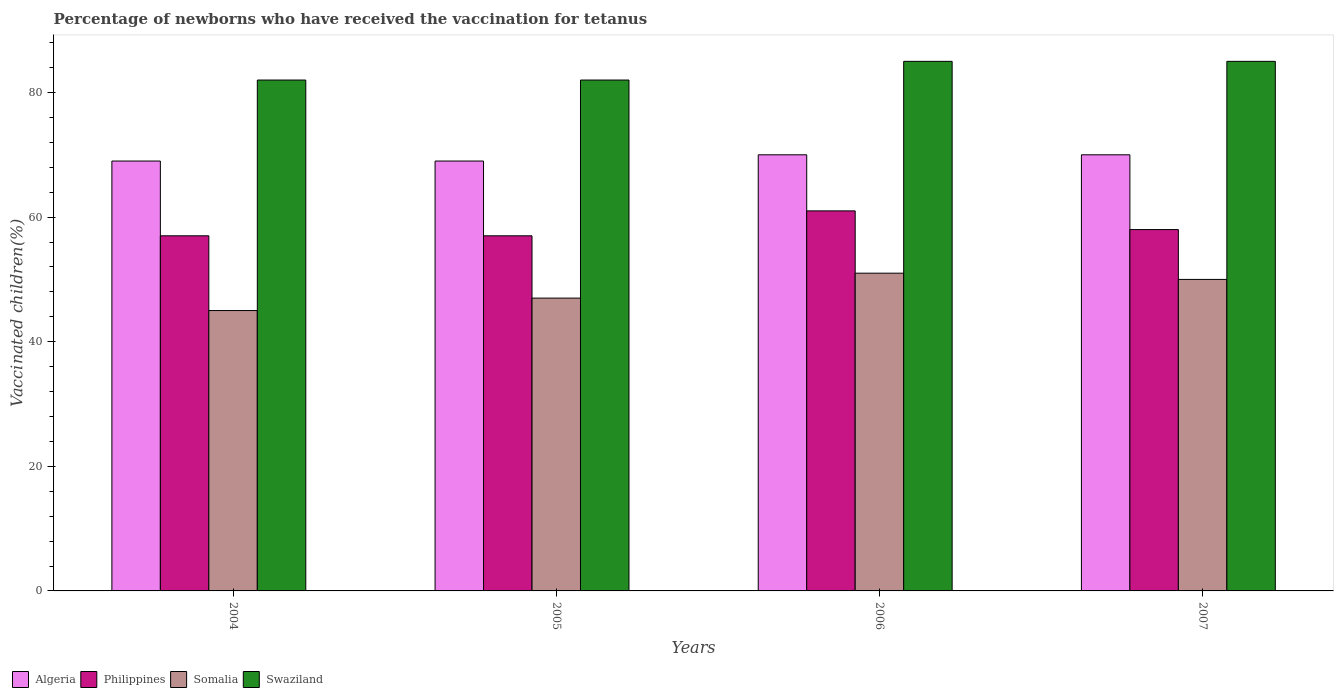In how many cases, is the number of bars for a given year not equal to the number of legend labels?
Your answer should be compact. 0. What is the percentage of vaccinated children in Philippines in 2006?
Keep it short and to the point. 61. Across all years, what is the minimum percentage of vaccinated children in Algeria?
Make the answer very short. 69. In which year was the percentage of vaccinated children in Philippines minimum?
Make the answer very short. 2004. What is the total percentage of vaccinated children in Swaziland in the graph?
Offer a very short reply. 334. What is the difference between the percentage of vaccinated children in Swaziland in 2005 and that in 2006?
Keep it short and to the point. -3. What is the difference between the percentage of vaccinated children in Somalia in 2007 and the percentage of vaccinated children in Swaziland in 2006?
Provide a succinct answer. -35. What is the average percentage of vaccinated children in Swaziland per year?
Offer a very short reply. 83.5. In the year 2005, what is the difference between the percentage of vaccinated children in Philippines and percentage of vaccinated children in Swaziland?
Provide a succinct answer. -25. In how many years, is the percentage of vaccinated children in Somalia greater than 8 %?
Provide a succinct answer. 4. What is the ratio of the percentage of vaccinated children in Philippines in 2004 to that in 2006?
Your response must be concise. 0.93. What is the difference between the highest and the second highest percentage of vaccinated children in Algeria?
Ensure brevity in your answer.  0. In how many years, is the percentage of vaccinated children in Somalia greater than the average percentage of vaccinated children in Somalia taken over all years?
Provide a succinct answer. 2. What does the 3rd bar from the left in 2005 represents?
Offer a terse response. Somalia. What does the 1st bar from the right in 2006 represents?
Keep it short and to the point. Swaziland. How many bars are there?
Ensure brevity in your answer.  16. Are the values on the major ticks of Y-axis written in scientific E-notation?
Your answer should be compact. No. What is the title of the graph?
Your response must be concise. Percentage of newborns who have received the vaccination for tetanus. What is the label or title of the Y-axis?
Provide a succinct answer. Vaccinated children(%). What is the Vaccinated children(%) of Algeria in 2004?
Give a very brief answer. 69. What is the Vaccinated children(%) of Swaziland in 2004?
Offer a very short reply. 82. What is the Vaccinated children(%) of Algeria in 2005?
Offer a terse response. 69. What is the Vaccinated children(%) in Philippines in 2005?
Your answer should be very brief. 57. What is the Vaccinated children(%) in Philippines in 2006?
Your response must be concise. 61. What is the Vaccinated children(%) in Swaziland in 2006?
Offer a very short reply. 85. What is the Vaccinated children(%) of Philippines in 2007?
Provide a short and direct response. 58. What is the Vaccinated children(%) in Swaziland in 2007?
Your answer should be very brief. 85. Across all years, what is the maximum Vaccinated children(%) in Philippines?
Keep it short and to the point. 61. Across all years, what is the minimum Vaccinated children(%) in Philippines?
Offer a terse response. 57. Across all years, what is the minimum Vaccinated children(%) in Swaziland?
Provide a short and direct response. 82. What is the total Vaccinated children(%) in Algeria in the graph?
Provide a short and direct response. 278. What is the total Vaccinated children(%) of Philippines in the graph?
Provide a short and direct response. 233. What is the total Vaccinated children(%) in Somalia in the graph?
Your answer should be very brief. 193. What is the total Vaccinated children(%) in Swaziland in the graph?
Your response must be concise. 334. What is the difference between the Vaccinated children(%) of Philippines in 2004 and that in 2005?
Your answer should be compact. 0. What is the difference between the Vaccinated children(%) of Somalia in 2004 and that in 2006?
Provide a succinct answer. -6. What is the difference between the Vaccinated children(%) in Swaziland in 2004 and that in 2006?
Provide a short and direct response. -3. What is the difference between the Vaccinated children(%) in Algeria in 2005 and that in 2007?
Your response must be concise. -1. What is the difference between the Vaccinated children(%) of Philippines in 2005 and that in 2007?
Your answer should be very brief. -1. What is the difference between the Vaccinated children(%) in Swaziland in 2005 and that in 2007?
Ensure brevity in your answer.  -3. What is the difference between the Vaccinated children(%) of Algeria in 2006 and that in 2007?
Your answer should be compact. 0. What is the difference between the Vaccinated children(%) in Algeria in 2004 and the Vaccinated children(%) in Philippines in 2005?
Your response must be concise. 12. What is the difference between the Vaccinated children(%) in Algeria in 2004 and the Vaccinated children(%) in Somalia in 2005?
Make the answer very short. 22. What is the difference between the Vaccinated children(%) in Algeria in 2004 and the Vaccinated children(%) in Swaziland in 2005?
Make the answer very short. -13. What is the difference between the Vaccinated children(%) in Philippines in 2004 and the Vaccinated children(%) in Somalia in 2005?
Make the answer very short. 10. What is the difference between the Vaccinated children(%) of Philippines in 2004 and the Vaccinated children(%) of Swaziland in 2005?
Your answer should be very brief. -25. What is the difference between the Vaccinated children(%) of Somalia in 2004 and the Vaccinated children(%) of Swaziland in 2005?
Offer a very short reply. -37. What is the difference between the Vaccinated children(%) of Philippines in 2004 and the Vaccinated children(%) of Somalia in 2006?
Ensure brevity in your answer.  6. What is the difference between the Vaccinated children(%) of Philippines in 2004 and the Vaccinated children(%) of Swaziland in 2006?
Provide a succinct answer. -28. What is the difference between the Vaccinated children(%) in Somalia in 2004 and the Vaccinated children(%) in Swaziland in 2006?
Provide a succinct answer. -40. What is the difference between the Vaccinated children(%) in Philippines in 2004 and the Vaccinated children(%) in Somalia in 2007?
Provide a short and direct response. 7. What is the difference between the Vaccinated children(%) of Philippines in 2004 and the Vaccinated children(%) of Swaziland in 2007?
Ensure brevity in your answer.  -28. What is the difference between the Vaccinated children(%) of Algeria in 2005 and the Vaccinated children(%) of Philippines in 2006?
Ensure brevity in your answer.  8. What is the difference between the Vaccinated children(%) of Algeria in 2005 and the Vaccinated children(%) of Swaziland in 2006?
Give a very brief answer. -16. What is the difference between the Vaccinated children(%) of Philippines in 2005 and the Vaccinated children(%) of Swaziland in 2006?
Provide a short and direct response. -28. What is the difference between the Vaccinated children(%) in Somalia in 2005 and the Vaccinated children(%) in Swaziland in 2006?
Your response must be concise. -38. What is the difference between the Vaccinated children(%) in Algeria in 2005 and the Vaccinated children(%) in Somalia in 2007?
Your answer should be compact. 19. What is the difference between the Vaccinated children(%) of Algeria in 2005 and the Vaccinated children(%) of Swaziland in 2007?
Make the answer very short. -16. What is the difference between the Vaccinated children(%) of Philippines in 2005 and the Vaccinated children(%) of Somalia in 2007?
Give a very brief answer. 7. What is the difference between the Vaccinated children(%) in Philippines in 2005 and the Vaccinated children(%) in Swaziland in 2007?
Keep it short and to the point. -28. What is the difference between the Vaccinated children(%) of Somalia in 2005 and the Vaccinated children(%) of Swaziland in 2007?
Offer a very short reply. -38. What is the difference between the Vaccinated children(%) in Algeria in 2006 and the Vaccinated children(%) in Somalia in 2007?
Give a very brief answer. 20. What is the difference between the Vaccinated children(%) of Somalia in 2006 and the Vaccinated children(%) of Swaziland in 2007?
Provide a succinct answer. -34. What is the average Vaccinated children(%) in Algeria per year?
Your answer should be very brief. 69.5. What is the average Vaccinated children(%) in Philippines per year?
Offer a terse response. 58.25. What is the average Vaccinated children(%) of Somalia per year?
Provide a succinct answer. 48.25. What is the average Vaccinated children(%) of Swaziland per year?
Offer a terse response. 83.5. In the year 2004, what is the difference between the Vaccinated children(%) of Algeria and Vaccinated children(%) of Somalia?
Provide a short and direct response. 24. In the year 2004, what is the difference between the Vaccinated children(%) of Algeria and Vaccinated children(%) of Swaziland?
Your answer should be very brief. -13. In the year 2004, what is the difference between the Vaccinated children(%) in Philippines and Vaccinated children(%) in Somalia?
Provide a succinct answer. 12. In the year 2004, what is the difference between the Vaccinated children(%) of Somalia and Vaccinated children(%) of Swaziland?
Provide a short and direct response. -37. In the year 2005, what is the difference between the Vaccinated children(%) of Algeria and Vaccinated children(%) of Philippines?
Offer a terse response. 12. In the year 2005, what is the difference between the Vaccinated children(%) in Algeria and Vaccinated children(%) in Swaziland?
Provide a short and direct response. -13. In the year 2005, what is the difference between the Vaccinated children(%) in Philippines and Vaccinated children(%) in Somalia?
Make the answer very short. 10. In the year 2005, what is the difference between the Vaccinated children(%) of Philippines and Vaccinated children(%) of Swaziland?
Give a very brief answer. -25. In the year 2005, what is the difference between the Vaccinated children(%) of Somalia and Vaccinated children(%) of Swaziland?
Ensure brevity in your answer.  -35. In the year 2006, what is the difference between the Vaccinated children(%) of Algeria and Vaccinated children(%) of Philippines?
Keep it short and to the point. 9. In the year 2006, what is the difference between the Vaccinated children(%) in Algeria and Vaccinated children(%) in Somalia?
Keep it short and to the point. 19. In the year 2006, what is the difference between the Vaccinated children(%) in Algeria and Vaccinated children(%) in Swaziland?
Provide a short and direct response. -15. In the year 2006, what is the difference between the Vaccinated children(%) in Philippines and Vaccinated children(%) in Somalia?
Ensure brevity in your answer.  10. In the year 2006, what is the difference between the Vaccinated children(%) in Somalia and Vaccinated children(%) in Swaziland?
Provide a short and direct response. -34. In the year 2007, what is the difference between the Vaccinated children(%) in Algeria and Vaccinated children(%) in Somalia?
Your answer should be compact. 20. In the year 2007, what is the difference between the Vaccinated children(%) of Somalia and Vaccinated children(%) of Swaziland?
Offer a terse response. -35. What is the ratio of the Vaccinated children(%) of Somalia in 2004 to that in 2005?
Your answer should be compact. 0.96. What is the ratio of the Vaccinated children(%) in Algeria in 2004 to that in 2006?
Make the answer very short. 0.99. What is the ratio of the Vaccinated children(%) in Philippines in 2004 to that in 2006?
Offer a terse response. 0.93. What is the ratio of the Vaccinated children(%) of Somalia in 2004 to that in 2006?
Give a very brief answer. 0.88. What is the ratio of the Vaccinated children(%) in Swaziland in 2004 to that in 2006?
Your answer should be very brief. 0.96. What is the ratio of the Vaccinated children(%) in Algeria in 2004 to that in 2007?
Ensure brevity in your answer.  0.99. What is the ratio of the Vaccinated children(%) in Philippines in 2004 to that in 2007?
Your response must be concise. 0.98. What is the ratio of the Vaccinated children(%) in Somalia in 2004 to that in 2007?
Give a very brief answer. 0.9. What is the ratio of the Vaccinated children(%) of Swaziland in 2004 to that in 2007?
Offer a terse response. 0.96. What is the ratio of the Vaccinated children(%) in Algeria in 2005 to that in 2006?
Give a very brief answer. 0.99. What is the ratio of the Vaccinated children(%) of Philippines in 2005 to that in 2006?
Your answer should be very brief. 0.93. What is the ratio of the Vaccinated children(%) in Somalia in 2005 to that in 2006?
Provide a short and direct response. 0.92. What is the ratio of the Vaccinated children(%) in Swaziland in 2005 to that in 2006?
Provide a succinct answer. 0.96. What is the ratio of the Vaccinated children(%) of Algeria in 2005 to that in 2007?
Give a very brief answer. 0.99. What is the ratio of the Vaccinated children(%) in Philippines in 2005 to that in 2007?
Keep it short and to the point. 0.98. What is the ratio of the Vaccinated children(%) of Swaziland in 2005 to that in 2007?
Make the answer very short. 0.96. What is the ratio of the Vaccinated children(%) of Algeria in 2006 to that in 2007?
Provide a succinct answer. 1. What is the ratio of the Vaccinated children(%) of Philippines in 2006 to that in 2007?
Make the answer very short. 1.05. What is the ratio of the Vaccinated children(%) of Somalia in 2006 to that in 2007?
Your answer should be compact. 1.02. What is the ratio of the Vaccinated children(%) in Swaziland in 2006 to that in 2007?
Make the answer very short. 1. What is the difference between the highest and the second highest Vaccinated children(%) of Algeria?
Give a very brief answer. 0. What is the difference between the highest and the second highest Vaccinated children(%) in Somalia?
Give a very brief answer. 1. What is the difference between the highest and the lowest Vaccinated children(%) in Philippines?
Your answer should be compact. 4. What is the difference between the highest and the lowest Vaccinated children(%) in Somalia?
Give a very brief answer. 6. What is the difference between the highest and the lowest Vaccinated children(%) in Swaziland?
Provide a short and direct response. 3. 